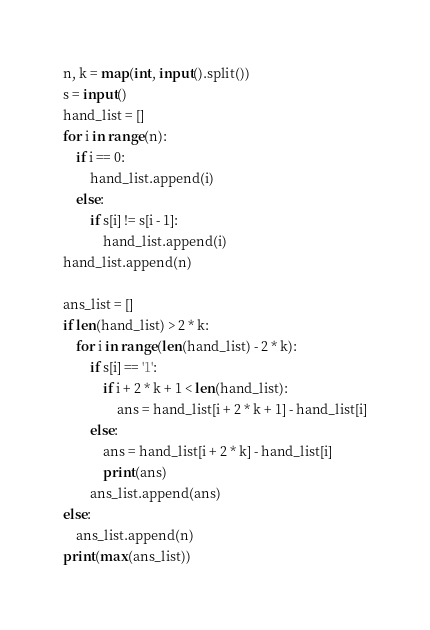<code> <loc_0><loc_0><loc_500><loc_500><_Python_>n, k = map(int, input().split())
s = input()
hand_list = []
for i in range(n):
    if i == 0:
        hand_list.append(i)
    else:
        if s[i] != s[i - 1]:
            hand_list.append(i)
hand_list.append(n)

ans_list = []
if len(hand_list) > 2 * k:
    for i in range(len(hand_list) - 2 * k):
        if s[i] == '1':
            if i + 2 * k + 1 < len(hand_list):
                ans = hand_list[i + 2 * k + 1] - hand_list[i]
        else:
            ans = hand_list[i + 2 * k] - hand_list[i]
            print(ans)
        ans_list.append(ans)
else:
    ans_list.append(n)
print(max(ans_list))</code> 